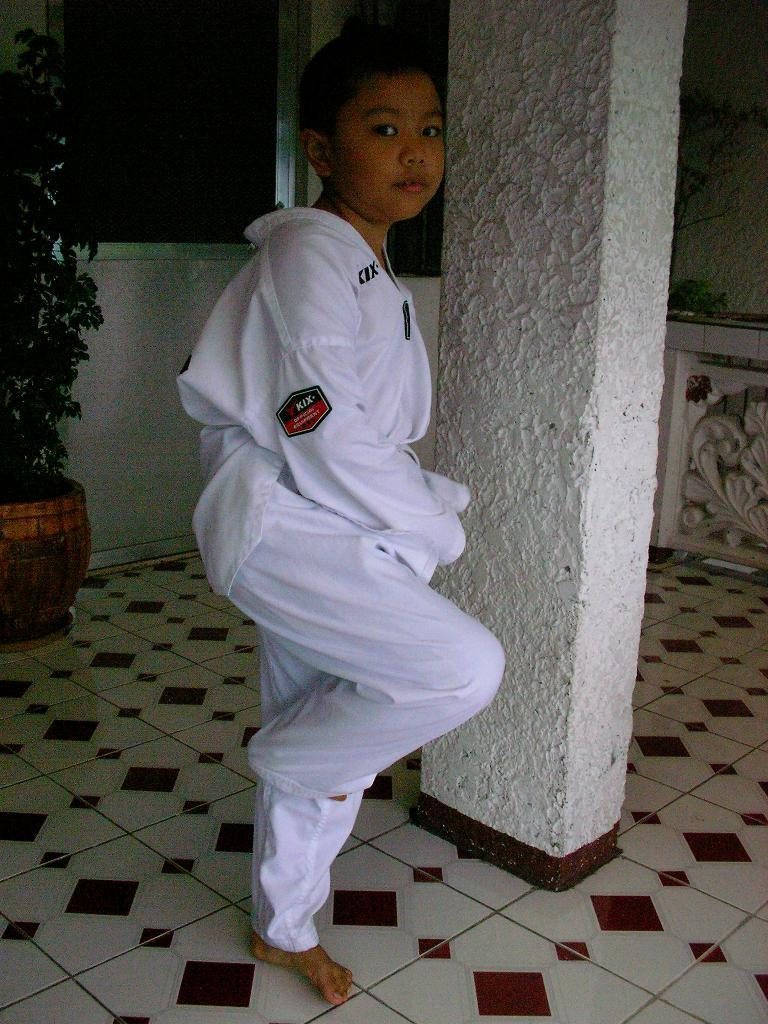What is the main subject of the image? There is a boy standing in the center of the image. What is the boy wearing? The boy is wearing a white costume. What can be seen in the background of the image? There is a wall, a plant pot, a plant, a pillar, and other objects in the background of the image. What type of current is flowing through the pan in the image? There is no pan present in the image, and therefore no current can be observed. 